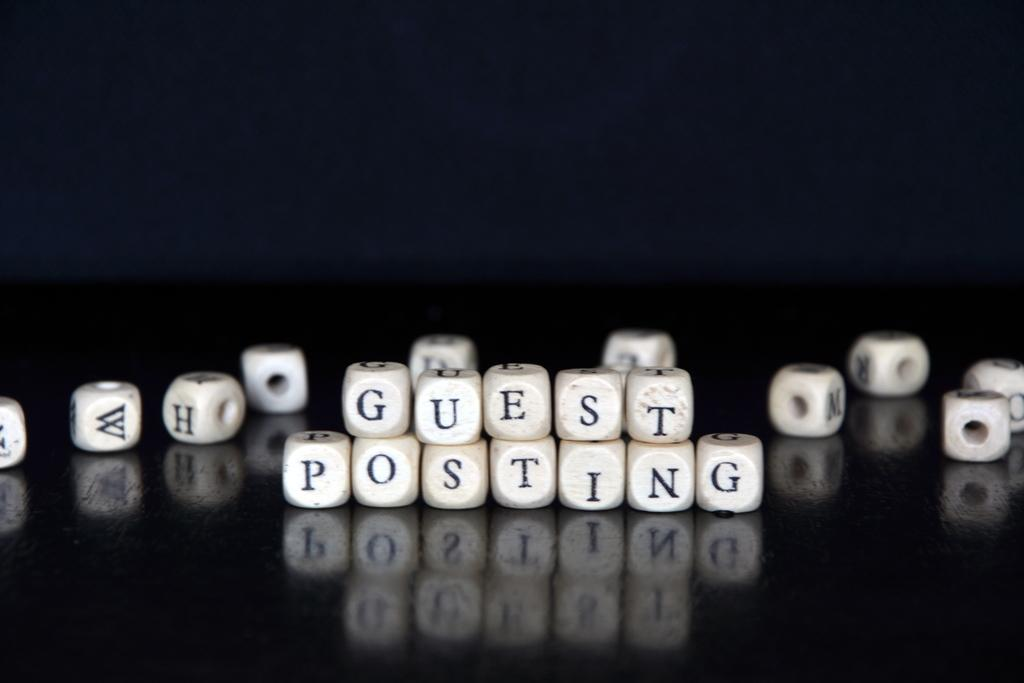What objects are present in the image? There are beads in the image. Where are the beads located? The beads are placed on a table. What type of grape is being used to create the beads in the image? There is no grape present in the image, nor are the beads made from grapes. 